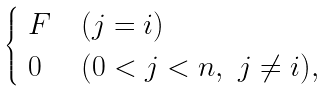Convert formula to latex. <formula><loc_0><loc_0><loc_500><loc_500>\begin{cases} \ F & ( j = i ) \\ \ 0 & ( 0 < j < n , \ j \neq i ) , \end{cases}</formula> 